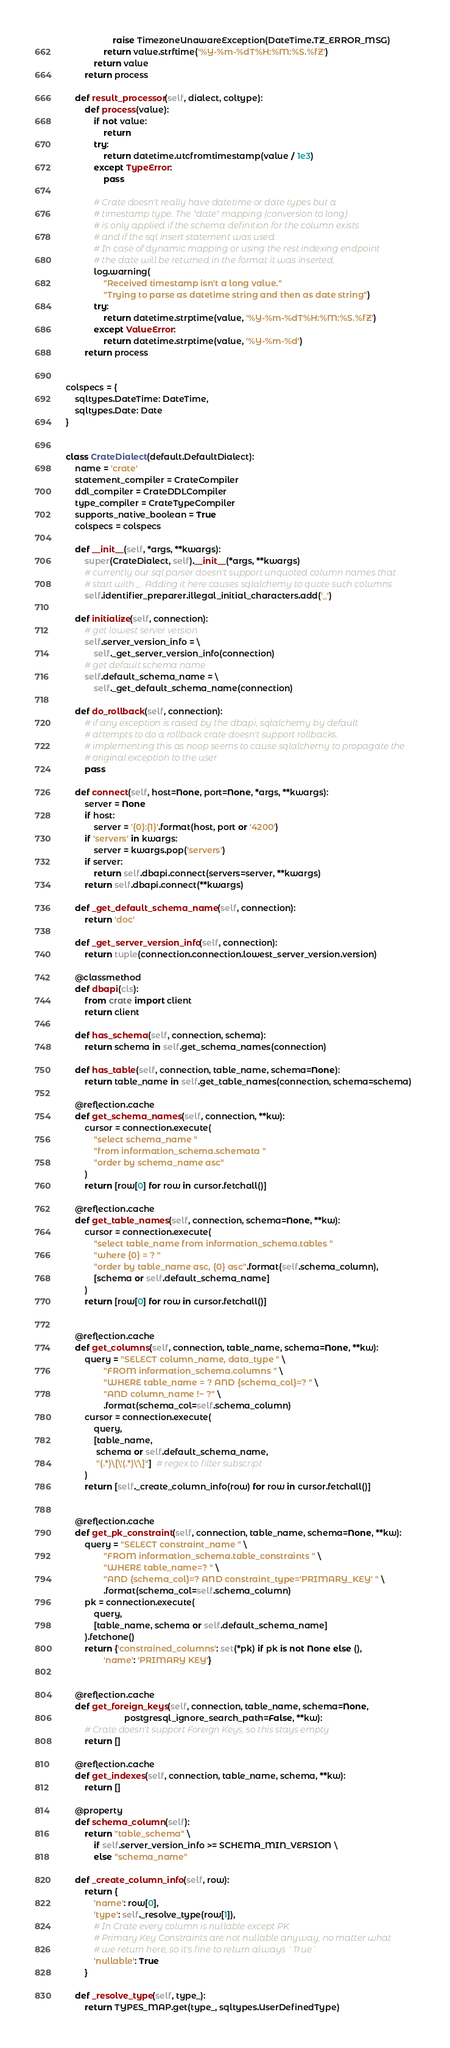<code> <loc_0><loc_0><loc_500><loc_500><_Python_>                    raise TimezoneUnawareException(DateTime.TZ_ERROR_MSG)
                return value.strftime('%Y-%m-%dT%H:%M:%S.%fZ')
            return value
        return process

    def result_processor(self, dialect, coltype):
        def process(value):
            if not value:
                return
            try:
                return datetime.utcfromtimestamp(value / 1e3)
            except TypeError:
                pass

            # Crate doesn't really have datetime or date types but a
            # timestamp type. The "date" mapping (conversion to long)
            # is only applied if the schema definition for the column exists
            # and if the sql insert statement was used.
            # In case of dynamic mapping or using the rest indexing endpoint
            # the date will be returned in the format it was inserted.
            log.warning(
                "Received timestamp isn't a long value."
                "Trying to parse as datetime string and then as date string")
            try:
                return datetime.strptime(value, '%Y-%m-%dT%H:%M:%S.%fZ')
            except ValueError:
                return datetime.strptime(value, '%Y-%m-%d')
        return process


colspecs = {
    sqltypes.DateTime: DateTime,
    sqltypes.Date: Date
}


class CrateDialect(default.DefaultDialect):
    name = 'crate'
    statement_compiler = CrateCompiler
    ddl_compiler = CrateDDLCompiler
    type_compiler = CrateTypeCompiler
    supports_native_boolean = True
    colspecs = colspecs

    def __init__(self, *args, **kwargs):
        super(CrateDialect, self).__init__(*args, **kwargs)
        # currently our sql parser doesn't support unquoted column names that
        # start with _. Adding it here causes sqlalchemy to quote such columns
        self.identifier_preparer.illegal_initial_characters.add('_')

    def initialize(self, connection):
        # get lowest server version
        self.server_version_info = \
            self._get_server_version_info(connection)
        # get default schema name
        self.default_schema_name = \
            self._get_default_schema_name(connection)

    def do_rollback(self, connection):
        # if any exception is raised by the dbapi, sqlalchemy by default
        # attempts to do a rollback crate doesn't support rollbacks.
        # implementing this as noop seems to cause sqlalchemy to propagate the
        # original exception to the user
        pass

    def connect(self, host=None, port=None, *args, **kwargs):
        server = None
        if host:
            server = '{0}:{1}'.format(host, port or '4200')
        if 'servers' in kwargs:
            server = kwargs.pop('servers')
        if server:
            return self.dbapi.connect(servers=server, **kwargs)
        return self.dbapi.connect(**kwargs)

    def _get_default_schema_name(self, connection):
        return 'doc'

    def _get_server_version_info(self, connection):
        return tuple(connection.connection.lowest_server_version.version)

    @classmethod
    def dbapi(cls):
        from crate import client
        return client

    def has_schema(self, connection, schema):
        return schema in self.get_schema_names(connection)

    def has_table(self, connection, table_name, schema=None):
        return table_name in self.get_table_names(connection, schema=schema)

    @reflection.cache
    def get_schema_names(self, connection, **kw):
        cursor = connection.execute(
            "select schema_name "
            "from information_schema.schemata "
            "order by schema_name asc"
        )
        return [row[0] for row in cursor.fetchall()]

    @reflection.cache
    def get_table_names(self, connection, schema=None, **kw):
        cursor = connection.execute(
            "select table_name from information_schema.tables "
            "where {0} = ? "
            "order by table_name asc, {0} asc".format(self.schema_column),
            [schema or self.default_schema_name]
        )
        return [row[0] for row in cursor.fetchall()]


    @reflection.cache
    def get_columns(self, connection, table_name, schema=None, **kw):
        query = "SELECT column_name, data_type " \
                "FROM information_schema.columns " \
                "WHERE table_name = ? AND {schema_col}=? " \
                "AND column_name !~ ?" \
                .format(schema_col=self.schema_column)
        cursor = connection.execute(
            query,
            [table_name,
             schema or self.default_schema_name,
             "(.*)\[\'(.*)\'\]"]  # regex to filter subscript
        )
        return [self._create_column_info(row) for row in cursor.fetchall()]


    @reflection.cache
    def get_pk_constraint(self, connection, table_name, schema=None, **kw):
        query = "SELECT constraint_name " \
                "FROM information_schema.table_constraints " \
                "WHERE table_name=? " \
                "AND {schema_col}=? AND constraint_type='PRIMARY_KEY' " \
                .format(schema_col=self.schema_column)
        pk = connection.execute(
            query,
            [table_name, schema or self.default_schema_name]
        ).fetchone()
        return {'constrained_columns': set(*pk) if pk is not None else (),
                'name': 'PRIMARY KEY'}


    @reflection.cache
    def get_foreign_keys(self, connection, table_name, schema=None,
                         postgresql_ignore_search_path=False, **kw):
        # Crate doesn't support Foreign Keys, so this stays empty
        return []

    @reflection.cache
    def get_indexes(self, connection, table_name, schema, **kw):
        return []

    @property
    def schema_column(self):
        return "table_schema" \
            if self.server_version_info >= SCHEMA_MIN_VERSION \
            else "schema_name"

    def _create_column_info(self, row):
        return {
            'name': row[0],
            'type': self._resolve_type(row[1]),
            # In Crate every column is nullable except PK
            # Primary Key Constraints are not nullable anyway, no matter what
            # we return here, so it's fine to return always `True`
            'nullable': True
        }

    def _resolve_type(self, type_):
        return TYPES_MAP.get(type_, sqltypes.UserDefinedType)
</code> 